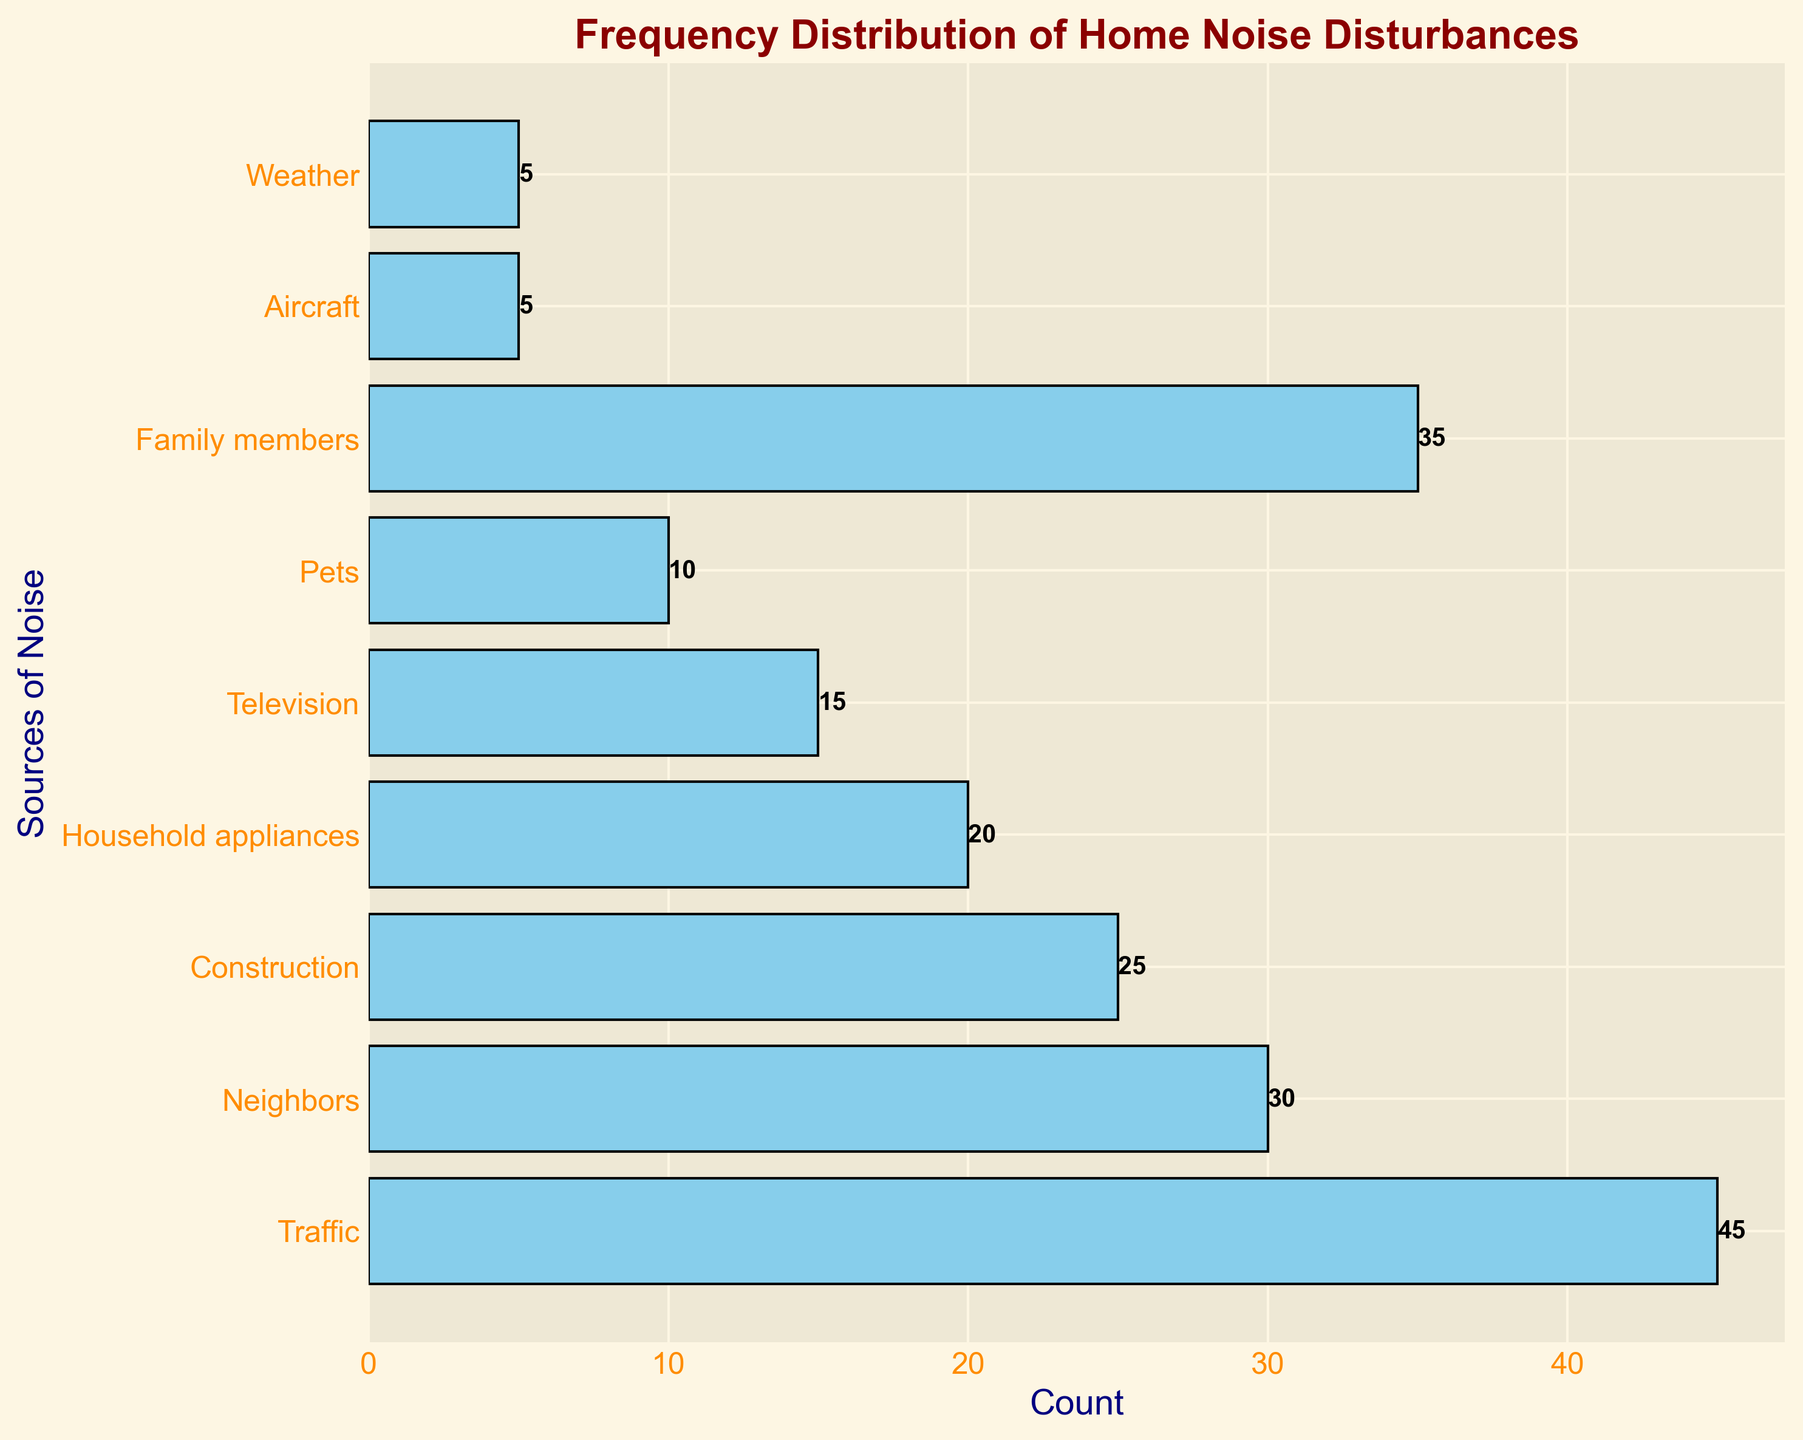Which source of noise disturbance has the highest frequency? To determine this, visually inspect the horizontal bars and identify which one is the longest. In this chart, the "Traffic" bar is the longest, representing the highest count.
Answer: Traffic Which source has the lowest frequency of noise disturbance? Look for the shortest horizontal bar in the chart. The bars for "Aircraft" and "Weather" are the shortest, each with a count of 5.
Answer: Aircraft and Weather How many more disturbances are attributed to family members compared to pets? Compare the bars for "Family members" and "Pets". The count for "Family members" is 35, and for "Pets", it is 10. The difference is 35 - 10.
Answer: 25 What is the combined frequency of noise disturbances from household appliances and television? Add the counts for "Household appliances" (20) and "Television" (15) together. The sum is 20 + 15.
Answer: 35 Which source contributes more noise, construction or neighbors? Compare the lengths of the bars for "Construction" and "Neighbors". The "Neighbors" bar has a count of 30, while "Construction" has a count of 25.
Answer: Neighbors By how much does the noise from traffic exceed the noise from household appliances? Subtract the count for "Household appliances" (20) from the count for "Traffic" (45). The difference is 45 - 20.
Answer: 25 What's the average frequency of noise disturbances for all the sources listed? Sum all the counts (45 + 30 + 25 + 20 + 15 + 10 + 35 + 5 + 5) and then divide by the number of sources (9). The calculation is (45 + 30 + 25 + 20 + 15 + 10 + 35 + 5 + 5) / 9.
Answer: 21.1 Which has a higher count, the sum of disturbances from pets and family members or the sum of disturbances from television and construction? Add the counts for "Pets" (10) and "Family members" (35) to get 45, and for "Television" (15) and "Construction" (25) to get 40. Compare the sums of 45 and 40, respectively.
Answer: Pets and Family members How does the frequency of disturbances from weather compare to those from aircraft? Compare the counts of "Weather" (5) and "Aircraft" (5). Both have the same frequency.
Answer: Equal 